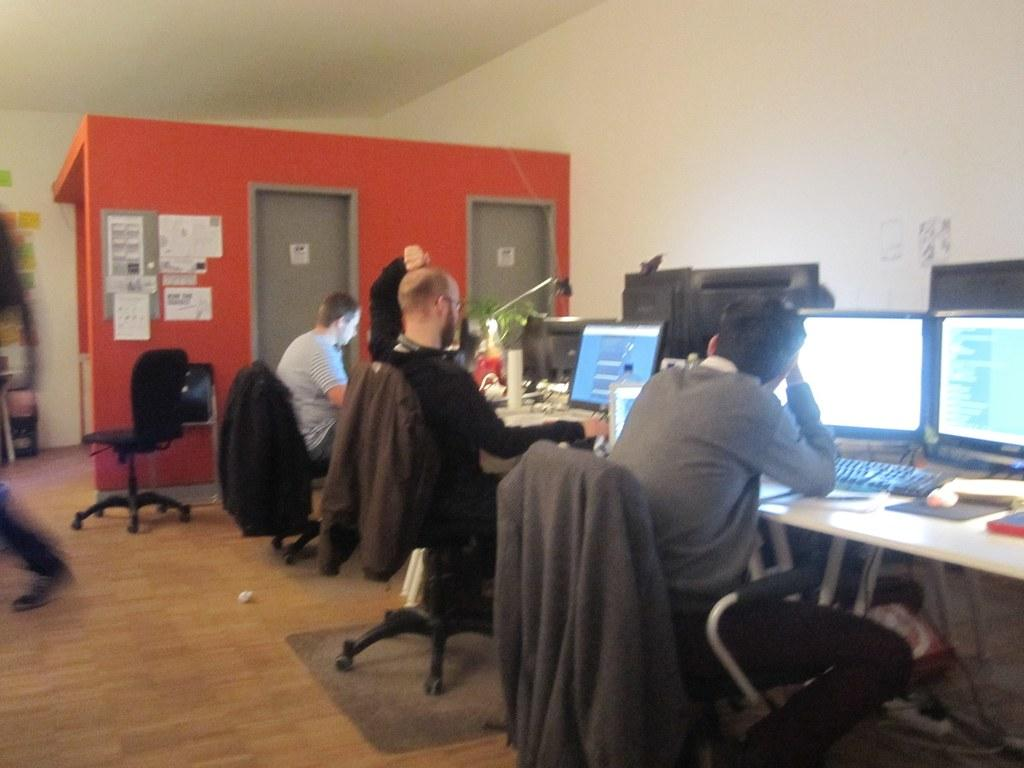What is the main setting of the image? There is a room in the image. How many people are in the room? There are three people sitting on chairs in the room. Where are the people positioned in relation to the desk? The people are in front of a desk. What can be found on the desk? There are systems (computers or electronic devices) and other items on the desk. What type of suit is the person on the left wearing in the image? There is no suit visible in the image; the people are not wearing any clothing mentioned. 